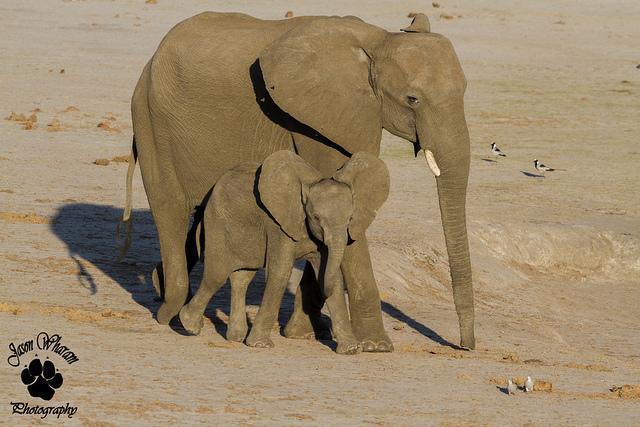How many adult elephants are in this scene?
Give a very brief answer. 1. How many elephants can you see?
Give a very brief answer. 2. How many people can be seen?
Give a very brief answer. 0. 